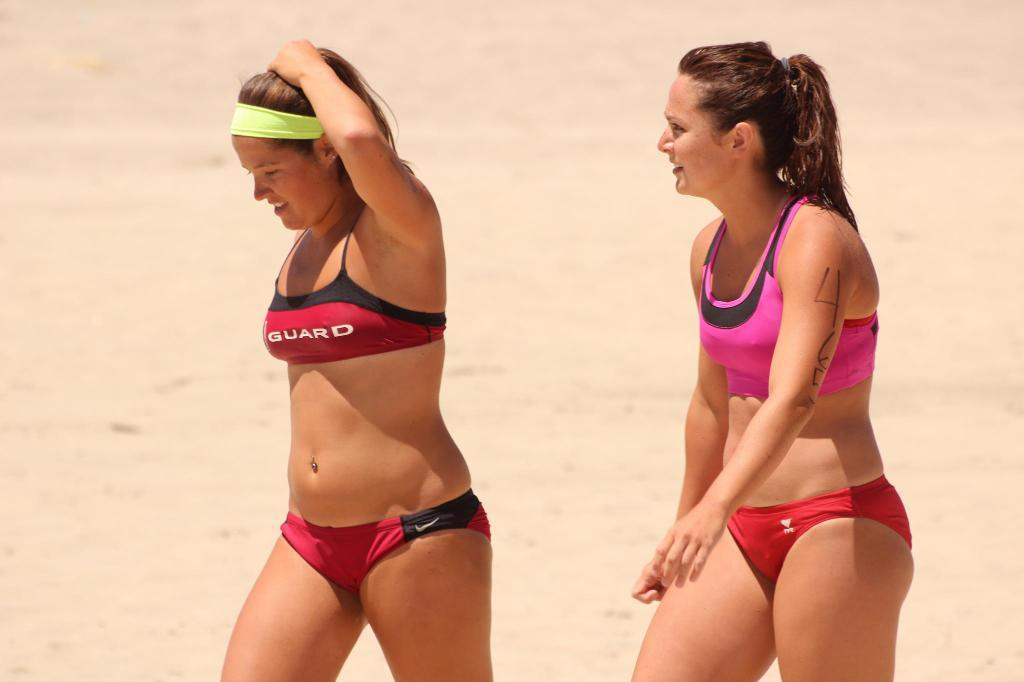How many people are in the image? There are two women in the image. What is the surface the women are standing on? The women are standing on the sand. What type of tub can be seen in the image? There is no tub present in the image; the women are standing on the sand. Whose birthday is being celebrated in the image? There is no indication of a birthday celebration in the image. 